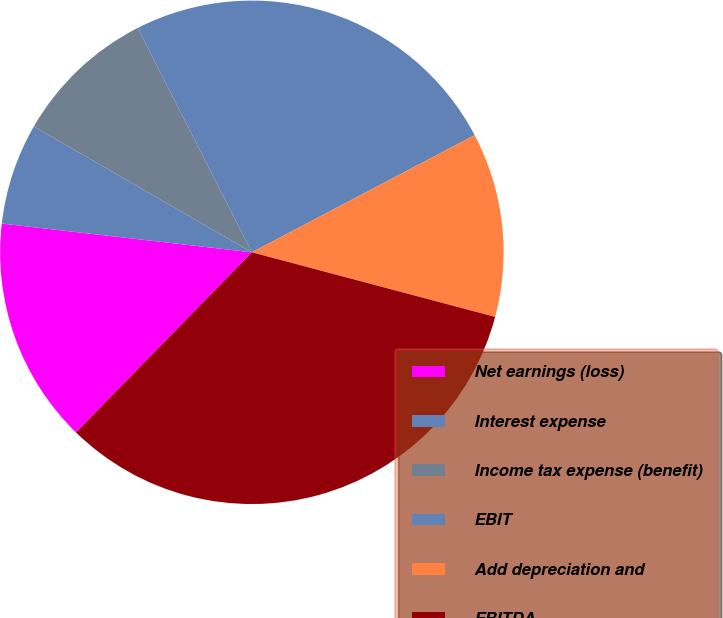<chart> <loc_0><loc_0><loc_500><loc_500><pie_chart><fcel>Net earnings (loss)<fcel>Interest expense<fcel>Income tax expense (benefit)<fcel>EBIT<fcel>Add depreciation and<fcel>EBITDA<nl><fcel>14.51%<fcel>6.51%<fcel>9.18%<fcel>24.78%<fcel>11.84%<fcel>33.18%<nl></chart> 